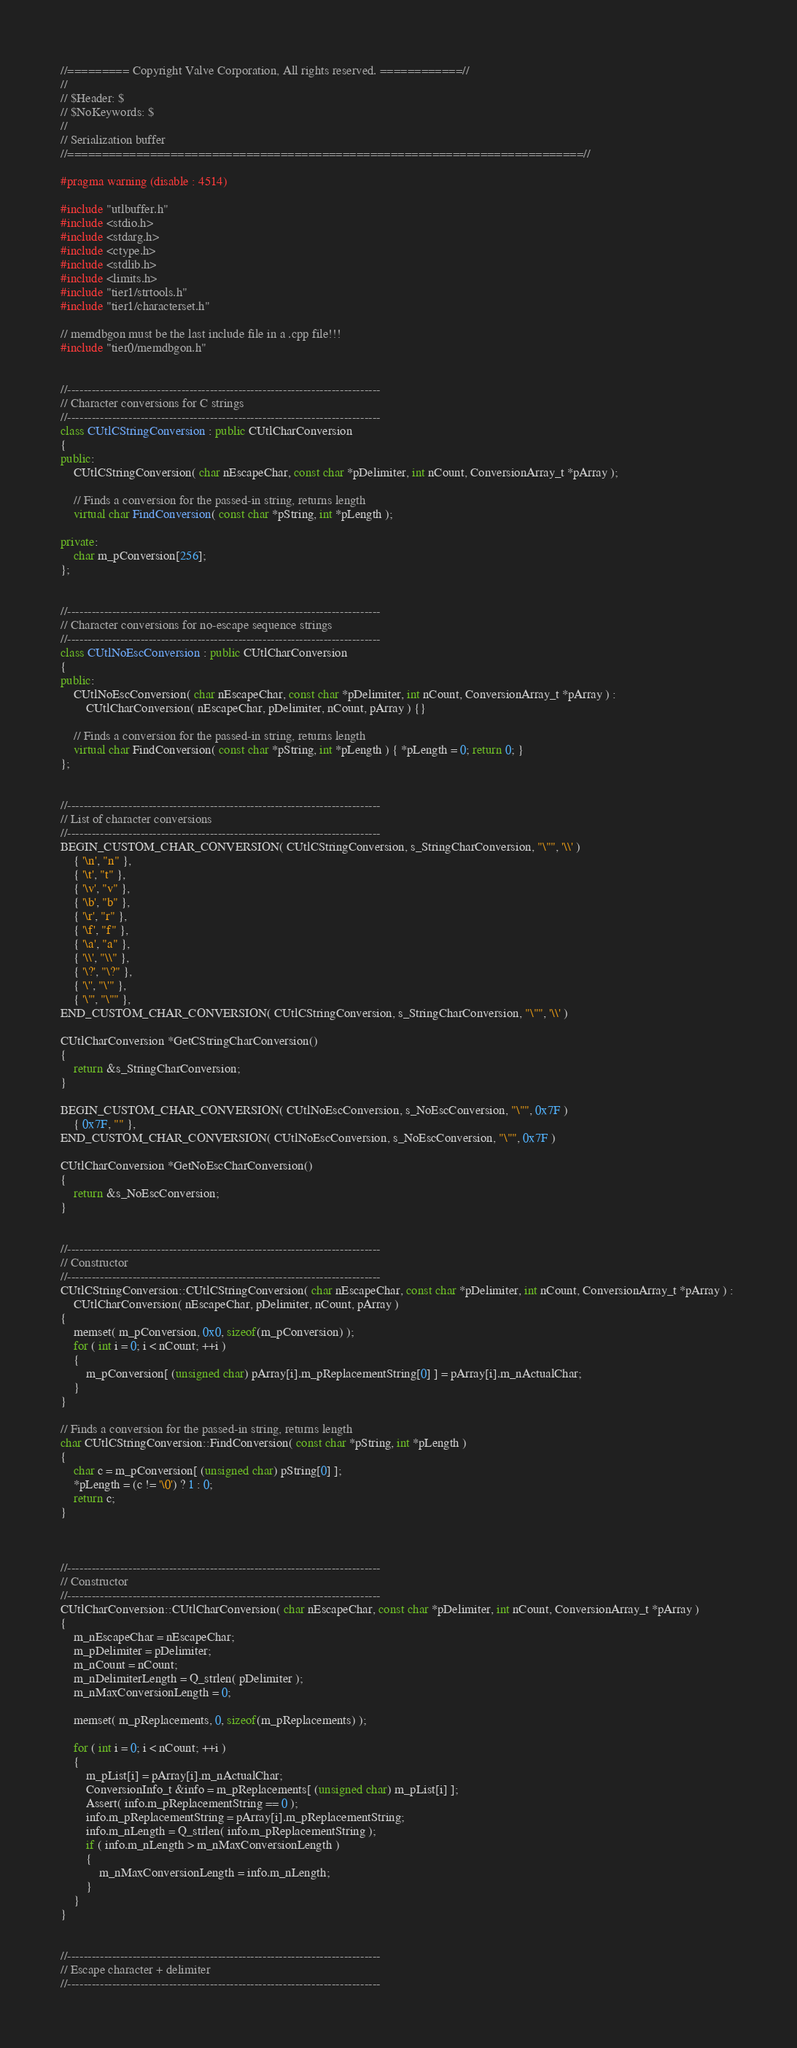Convert code to text. <code><loc_0><loc_0><loc_500><loc_500><_C++_>//========= Copyright Valve Corporation, All rights reserved. ============//
//
// $Header: $
// $NoKeywords: $
//
// Serialization buffer
//===========================================================================//

#pragma warning (disable : 4514)

#include "utlbuffer.h"
#include <stdio.h>
#include <stdarg.h>
#include <ctype.h>
#include <stdlib.h>
#include <limits.h>
#include "tier1/strtools.h"
#include "tier1/characterset.h"

// memdbgon must be the last include file in a .cpp file!!!
#include "tier0/memdbgon.h"
			    

//-----------------------------------------------------------------------------
// Character conversions for C strings
//-----------------------------------------------------------------------------
class CUtlCStringConversion : public CUtlCharConversion
{
public:
	CUtlCStringConversion( char nEscapeChar, const char *pDelimiter, int nCount, ConversionArray_t *pArray );

	// Finds a conversion for the passed-in string, returns length
	virtual char FindConversion( const char *pString, int *pLength );

private:
	char m_pConversion[256];
};


//-----------------------------------------------------------------------------
// Character conversions for no-escape sequence strings
//-----------------------------------------------------------------------------
class CUtlNoEscConversion : public CUtlCharConversion
{
public:
	CUtlNoEscConversion( char nEscapeChar, const char *pDelimiter, int nCount, ConversionArray_t *pArray ) :
		CUtlCharConversion( nEscapeChar, pDelimiter, nCount, pArray ) {}

	// Finds a conversion for the passed-in string, returns length
	virtual char FindConversion( const char *pString, int *pLength ) { *pLength = 0; return 0; }
};


//-----------------------------------------------------------------------------
// List of character conversions
//-----------------------------------------------------------------------------
BEGIN_CUSTOM_CHAR_CONVERSION( CUtlCStringConversion, s_StringCharConversion, "\"", '\\' )
	{ '\n', "n" },
	{ '\t', "t" },
	{ '\v', "v" },
	{ '\b', "b" },
	{ '\r', "r" },
	{ '\f', "f" },
	{ '\a', "a" },
	{ '\\', "\\" },
	{ '\?', "\?" },
	{ '\'', "\'" },
	{ '\"', "\"" },
END_CUSTOM_CHAR_CONVERSION( CUtlCStringConversion, s_StringCharConversion, "\"", '\\' )

CUtlCharConversion *GetCStringCharConversion()
{
	return &s_StringCharConversion;
}

BEGIN_CUSTOM_CHAR_CONVERSION( CUtlNoEscConversion, s_NoEscConversion, "\"", 0x7F )
	{ 0x7F, "" },
END_CUSTOM_CHAR_CONVERSION( CUtlNoEscConversion, s_NoEscConversion, "\"", 0x7F )

CUtlCharConversion *GetNoEscCharConversion()
{
	return &s_NoEscConversion;
}


//-----------------------------------------------------------------------------
// Constructor
//-----------------------------------------------------------------------------
CUtlCStringConversion::CUtlCStringConversion( char nEscapeChar, const char *pDelimiter, int nCount, ConversionArray_t *pArray ) : 
	CUtlCharConversion( nEscapeChar, pDelimiter, nCount, pArray )
{
	memset( m_pConversion, 0x0, sizeof(m_pConversion) );
	for ( int i = 0; i < nCount; ++i )
	{
		m_pConversion[ (unsigned char) pArray[i].m_pReplacementString[0] ] = pArray[i].m_nActualChar;
	}
}

// Finds a conversion for the passed-in string, returns length
char CUtlCStringConversion::FindConversion( const char *pString, int *pLength )
{
	char c = m_pConversion[ (unsigned char) pString[0] ];
	*pLength = (c != '\0') ? 1 : 0;
	return c;
}



//-----------------------------------------------------------------------------
// Constructor
//-----------------------------------------------------------------------------
CUtlCharConversion::CUtlCharConversion( char nEscapeChar, const char *pDelimiter, int nCount, ConversionArray_t *pArray )
{
	m_nEscapeChar = nEscapeChar;
	m_pDelimiter = pDelimiter;
	m_nCount = nCount;
	m_nDelimiterLength = Q_strlen( pDelimiter );
	m_nMaxConversionLength = 0;

	memset( m_pReplacements, 0, sizeof(m_pReplacements) );

	for ( int i = 0; i < nCount; ++i )
	{
		m_pList[i] = pArray[i].m_nActualChar;
		ConversionInfo_t &info = m_pReplacements[ (unsigned char) m_pList[i] ];
		Assert( info.m_pReplacementString == 0 );
		info.m_pReplacementString = pArray[i].m_pReplacementString;
		info.m_nLength = Q_strlen( info.m_pReplacementString );
		if ( info.m_nLength > m_nMaxConversionLength )
		{
			m_nMaxConversionLength = info.m_nLength;
		}
	}
}


//-----------------------------------------------------------------------------
// Escape character + delimiter
//-----------------------------------------------------------------------------</code> 